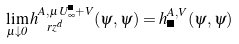Convert formula to latex. <formula><loc_0><loc_0><loc_500><loc_500>\lim _ { \mu \downarrow 0 } h _ { \ r z ^ { d } } ^ { A , \, \mu U _ { \infty } ^ { \Lambda } + V } ( \psi , \psi ) = h _ { \Lambda } ^ { A , V } ( \psi , \psi )</formula> 